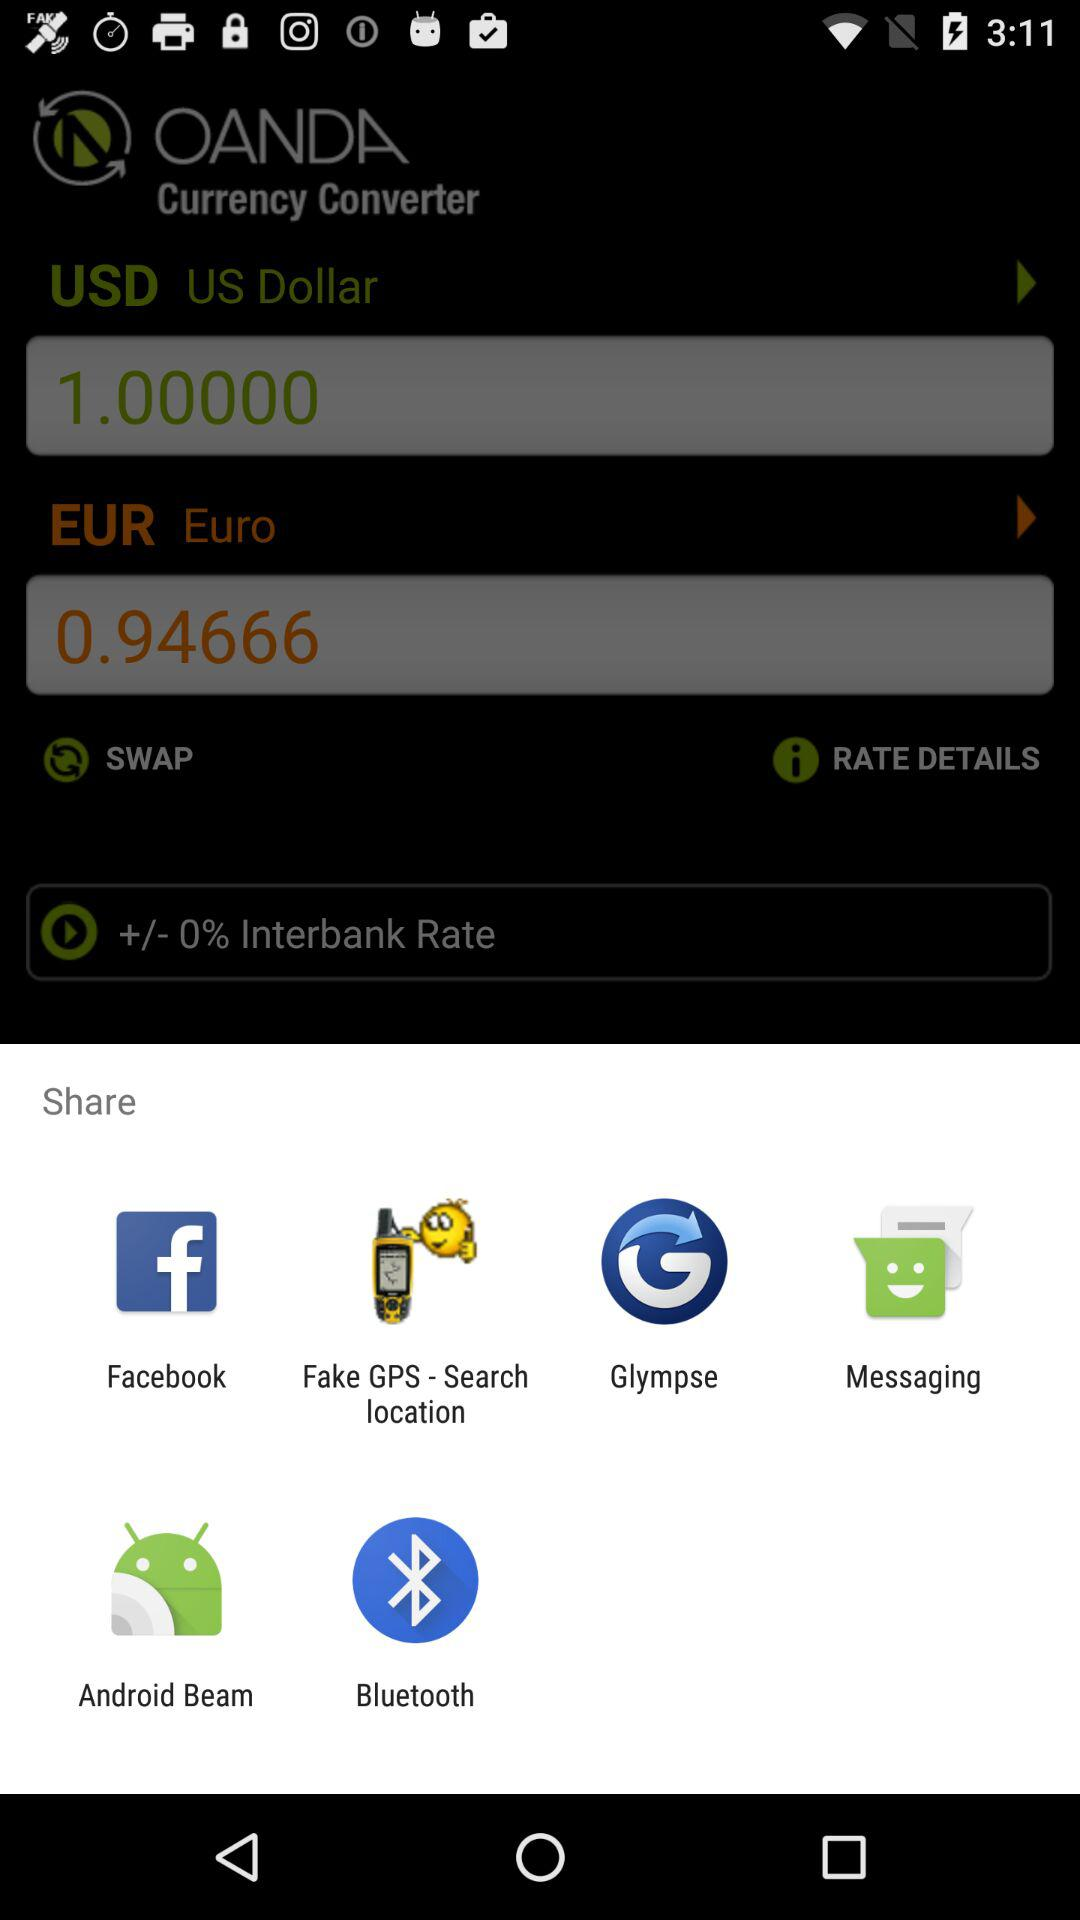How much more is the USD amount compared to the EUR amount?
Answer the question using a single word or phrase. 0.05334 